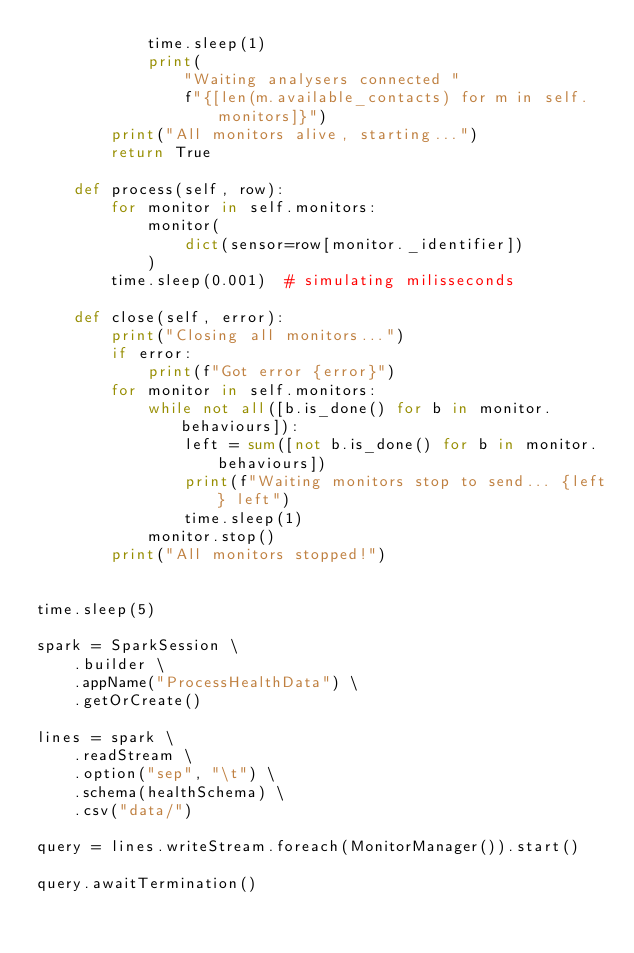Convert code to text. <code><loc_0><loc_0><loc_500><loc_500><_Python_>            time.sleep(1)
            print(
                "Waiting analysers connected "
                f"{[len(m.available_contacts) for m in self.monitors]}")
        print("All monitors alive, starting...")
        return True

    def process(self, row):
        for monitor in self.monitors:
            monitor(
                dict(sensor=row[monitor._identifier])
            )
        time.sleep(0.001)  # simulating milisseconds

    def close(self, error):
        print("Closing all monitors...")
        if error:
            print(f"Got error {error}")
        for monitor in self.monitors:
            while not all([b.is_done() for b in monitor.behaviours]):
                left = sum([not b.is_done() for b in monitor.behaviours])
                print(f"Waiting monitors stop to send... {left} left")
                time.sleep(1)
            monitor.stop()
        print("All monitors stopped!")


time.sleep(5)

spark = SparkSession \
    .builder \
    .appName("ProcessHealthData") \
    .getOrCreate()

lines = spark \
    .readStream \
    .option("sep", "\t") \
    .schema(healthSchema) \
    .csv("data/")

query = lines.writeStream.foreach(MonitorManager()).start()

query.awaitTermination()
</code> 